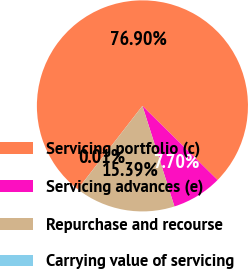<chart> <loc_0><loc_0><loc_500><loc_500><pie_chart><fcel>Servicing portfolio (c)<fcel>Servicing advances (e)<fcel>Repurchase and recourse<fcel>Carrying value of servicing<nl><fcel>76.89%<fcel>7.7%<fcel>15.39%<fcel>0.01%<nl></chart> 